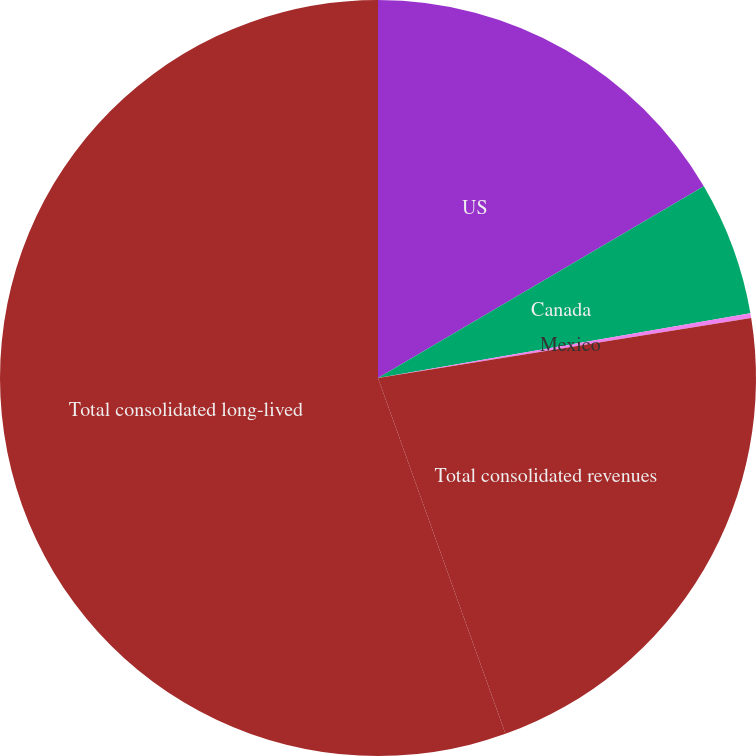Convert chart to OTSL. <chart><loc_0><loc_0><loc_500><loc_500><pie_chart><fcel>US<fcel>Canada<fcel>Mexico<fcel>Total consolidated revenues<fcel>Total consolidated long-lived<nl><fcel>16.54%<fcel>5.72%<fcel>0.2%<fcel>22.07%<fcel>55.48%<nl></chart> 